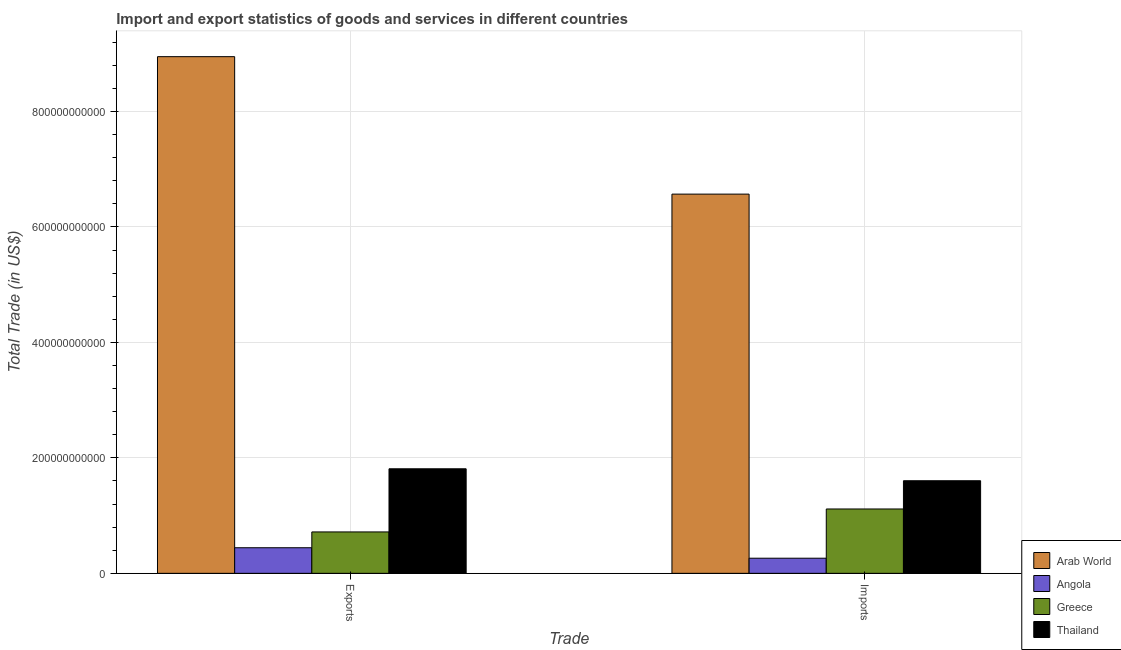How many different coloured bars are there?
Ensure brevity in your answer.  4. Are the number of bars per tick equal to the number of legend labels?
Your response must be concise. Yes. How many bars are there on the 1st tick from the left?
Your answer should be very brief. 4. How many bars are there on the 1st tick from the right?
Your answer should be compact. 4. What is the label of the 1st group of bars from the left?
Offer a very short reply. Exports. What is the export of goods and services in Angola?
Provide a short and direct response. 4.43e+1. Across all countries, what is the maximum export of goods and services?
Keep it short and to the point. 8.95e+11. Across all countries, what is the minimum imports of goods and services?
Ensure brevity in your answer.  2.62e+1. In which country was the imports of goods and services maximum?
Your response must be concise. Arab World. In which country was the imports of goods and services minimum?
Give a very brief answer. Angola. What is the total export of goods and services in the graph?
Give a very brief answer. 1.19e+12. What is the difference between the export of goods and services in Greece and that in Thailand?
Your answer should be very brief. -1.09e+11. What is the difference between the export of goods and services in Thailand and the imports of goods and services in Angola?
Provide a short and direct response. 1.55e+11. What is the average export of goods and services per country?
Your answer should be very brief. 2.98e+11. What is the difference between the export of goods and services and imports of goods and services in Greece?
Make the answer very short. -3.98e+1. What is the ratio of the imports of goods and services in Arab World to that in Thailand?
Keep it short and to the point. 4.1. What does the 3rd bar from the left in Exports represents?
Ensure brevity in your answer.  Greece. What does the 1st bar from the right in Imports represents?
Ensure brevity in your answer.  Thailand. How many countries are there in the graph?
Ensure brevity in your answer.  4. What is the difference between two consecutive major ticks on the Y-axis?
Your response must be concise. 2.00e+11. Does the graph contain grids?
Offer a very short reply. Yes. Where does the legend appear in the graph?
Your answer should be very brief. Bottom right. How are the legend labels stacked?
Your answer should be very brief. Vertical. What is the title of the graph?
Your answer should be compact. Import and export statistics of goods and services in different countries. Does "Jordan" appear as one of the legend labels in the graph?
Your answer should be compact. No. What is the label or title of the X-axis?
Ensure brevity in your answer.  Trade. What is the label or title of the Y-axis?
Ensure brevity in your answer.  Total Trade (in US$). What is the Total Trade (in US$) in Arab World in Exports?
Offer a very short reply. 8.95e+11. What is the Total Trade (in US$) in Angola in Exports?
Offer a very short reply. 4.43e+1. What is the Total Trade (in US$) in Greece in Exports?
Provide a short and direct response. 7.17e+1. What is the Total Trade (in US$) of Thailand in Exports?
Make the answer very short. 1.81e+11. What is the Total Trade (in US$) of Arab World in Imports?
Make the answer very short. 6.57e+11. What is the Total Trade (in US$) in Angola in Imports?
Make the answer very short. 2.62e+1. What is the Total Trade (in US$) of Greece in Imports?
Your answer should be very brief. 1.11e+11. What is the Total Trade (in US$) of Thailand in Imports?
Make the answer very short. 1.60e+11. Across all Trade, what is the maximum Total Trade (in US$) in Arab World?
Provide a succinct answer. 8.95e+11. Across all Trade, what is the maximum Total Trade (in US$) of Angola?
Provide a short and direct response. 4.43e+1. Across all Trade, what is the maximum Total Trade (in US$) in Greece?
Keep it short and to the point. 1.11e+11. Across all Trade, what is the maximum Total Trade (in US$) in Thailand?
Ensure brevity in your answer.  1.81e+11. Across all Trade, what is the minimum Total Trade (in US$) of Arab World?
Offer a terse response. 6.57e+11. Across all Trade, what is the minimum Total Trade (in US$) of Angola?
Ensure brevity in your answer.  2.62e+1. Across all Trade, what is the minimum Total Trade (in US$) in Greece?
Ensure brevity in your answer.  7.17e+1. Across all Trade, what is the minimum Total Trade (in US$) in Thailand?
Offer a very short reply. 1.60e+11. What is the total Total Trade (in US$) in Arab World in the graph?
Provide a short and direct response. 1.55e+12. What is the total Total Trade (in US$) of Angola in the graph?
Give a very brief answer. 7.05e+1. What is the total Total Trade (in US$) of Greece in the graph?
Make the answer very short. 1.83e+11. What is the total Total Trade (in US$) of Thailand in the graph?
Ensure brevity in your answer.  3.41e+11. What is the difference between the Total Trade (in US$) in Arab World in Exports and that in Imports?
Keep it short and to the point. 2.38e+11. What is the difference between the Total Trade (in US$) in Angola in Exports and that in Imports?
Keep it short and to the point. 1.81e+1. What is the difference between the Total Trade (in US$) of Greece in Exports and that in Imports?
Provide a succinct answer. -3.98e+1. What is the difference between the Total Trade (in US$) of Thailand in Exports and that in Imports?
Give a very brief answer. 2.07e+1. What is the difference between the Total Trade (in US$) in Arab World in Exports and the Total Trade (in US$) in Angola in Imports?
Make the answer very short. 8.69e+11. What is the difference between the Total Trade (in US$) of Arab World in Exports and the Total Trade (in US$) of Greece in Imports?
Give a very brief answer. 7.84e+11. What is the difference between the Total Trade (in US$) in Arab World in Exports and the Total Trade (in US$) in Thailand in Imports?
Offer a very short reply. 7.35e+11. What is the difference between the Total Trade (in US$) of Angola in Exports and the Total Trade (in US$) of Greece in Imports?
Provide a short and direct response. -6.72e+1. What is the difference between the Total Trade (in US$) of Angola in Exports and the Total Trade (in US$) of Thailand in Imports?
Your answer should be very brief. -1.16e+11. What is the difference between the Total Trade (in US$) of Greece in Exports and the Total Trade (in US$) of Thailand in Imports?
Your response must be concise. -8.87e+1. What is the average Total Trade (in US$) of Arab World per Trade?
Provide a succinct answer. 7.76e+11. What is the average Total Trade (in US$) in Angola per Trade?
Offer a very short reply. 3.53e+1. What is the average Total Trade (in US$) in Greece per Trade?
Provide a succinct answer. 9.16e+1. What is the average Total Trade (in US$) in Thailand per Trade?
Offer a terse response. 1.71e+11. What is the difference between the Total Trade (in US$) of Arab World and Total Trade (in US$) of Angola in Exports?
Make the answer very short. 8.51e+11. What is the difference between the Total Trade (in US$) in Arab World and Total Trade (in US$) in Greece in Exports?
Give a very brief answer. 8.23e+11. What is the difference between the Total Trade (in US$) in Arab World and Total Trade (in US$) in Thailand in Exports?
Provide a succinct answer. 7.14e+11. What is the difference between the Total Trade (in US$) of Angola and Total Trade (in US$) of Greece in Exports?
Offer a very short reply. -2.74e+1. What is the difference between the Total Trade (in US$) of Angola and Total Trade (in US$) of Thailand in Exports?
Make the answer very short. -1.37e+11. What is the difference between the Total Trade (in US$) of Greece and Total Trade (in US$) of Thailand in Exports?
Give a very brief answer. -1.09e+11. What is the difference between the Total Trade (in US$) of Arab World and Total Trade (in US$) of Angola in Imports?
Offer a terse response. 6.31e+11. What is the difference between the Total Trade (in US$) of Arab World and Total Trade (in US$) of Greece in Imports?
Your answer should be compact. 5.45e+11. What is the difference between the Total Trade (in US$) of Arab World and Total Trade (in US$) of Thailand in Imports?
Ensure brevity in your answer.  4.97e+11. What is the difference between the Total Trade (in US$) in Angola and Total Trade (in US$) in Greece in Imports?
Offer a terse response. -8.53e+1. What is the difference between the Total Trade (in US$) in Angola and Total Trade (in US$) in Thailand in Imports?
Provide a short and direct response. -1.34e+11. What is the difference between the Total Trade (in US$) of Greece and Total Trade (in US$) of Thailand in Imports?
Provide a short and direct response. -4.89e+1. What is the ratio of the Total Trade (in US$) in Arab World in Exports to that in Imports?
Give a very brief answer. 1.36. What is the ratio of the Total Trade (in US$) of Angola in Exports to that in Imports?
Keep it short and to the point. 1.69. What is the ratio of the Total Trade (in US$) in Greece in Exports to that in Imports?
Keep it short and to the point. 0.64. What is the ratio of the Total Trade (in US$) in Thailand in Exports to that in Imports?
Make the answer very short. 1.13. What is the difference between the highest and the second highest Total Trade (in US$) in Arab World?
Give a very brief answer. 2.38e+11. What is the difference between the highest and the second highest Total Trade (in US$) in Angola?
Keep it short and to the point. 1.81e+1. What is the difference between the highest and the second highest Total Trade (in US$) in Greece?
Your response must be concise. 3.98e+1. What is the difference between the highest and the second highest Total Trade (in US$) of Thailand?
Provide a short and direct response. 2.07e+1. What is the difference between the highest and the lowest Total Trade (in US$) of Arab World?
Offer a terse response. 2.38e+11. What is the difference between the highest and the lowest Total Trade (in US$) of Angola?
Offer a terse response. 1.81e+1. What is the difference between the highest and the lowest Total Trade (in US$) of Greece?
Your answer should be compact. 3.98e+1. What is the difference between the highest and the lowest Total Trade (in US$) in Thailand?
Offer a terse response. 2.07e+1. 